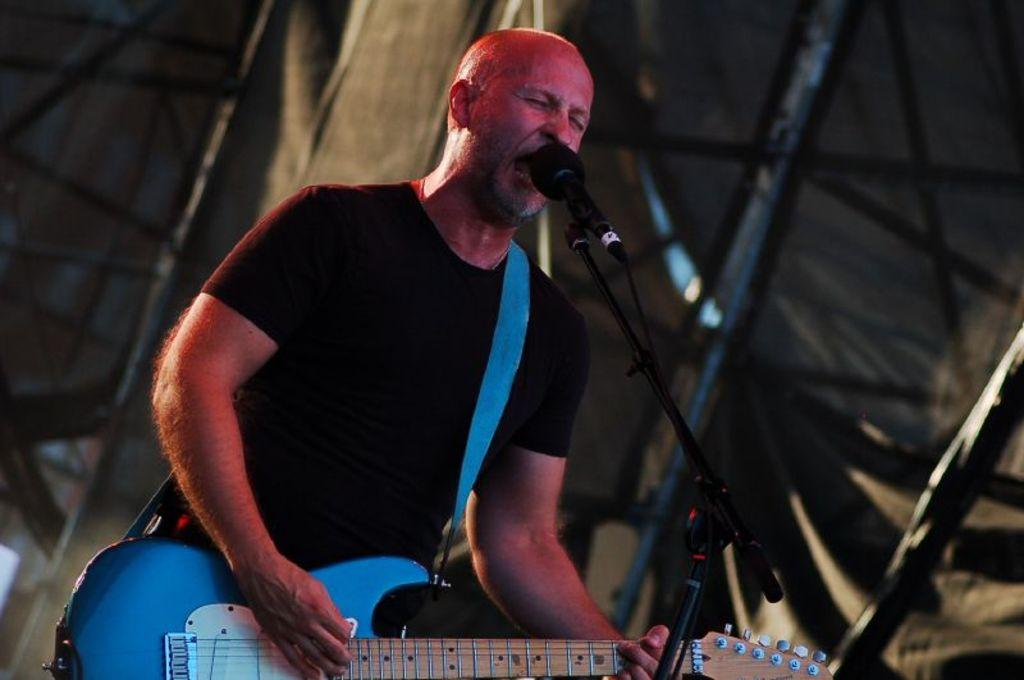What is the man in the image doing? The man is playing the guitar and singing on a mic. What instrument is the man holding in the image? The man is holding a guitar in the image. What can be seen in the background of the image? There is cloth and rods in the background of the image. What type of calculator is the man using to help him sing in the image? There is no calculator present in the image, and the man is not using any device to help him sing. 